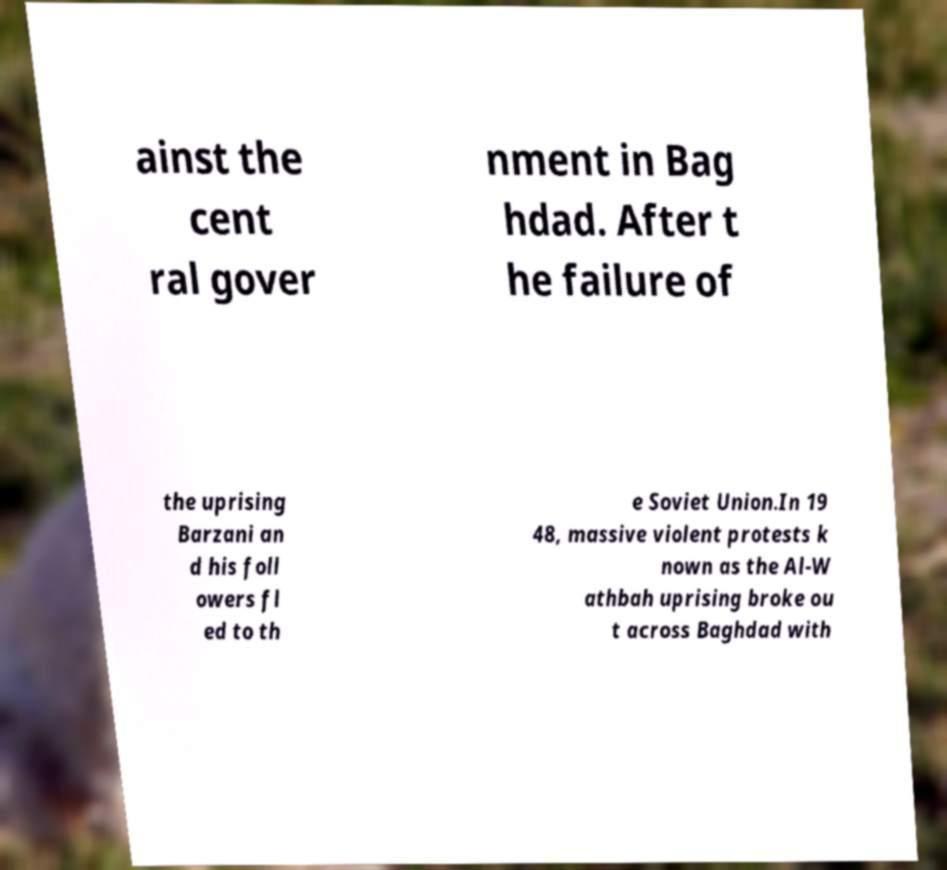I need the written content from this picture converted into text. Can you do that? ainst the cent ral gover nment in Bag hdad. After t he failure of the uprising Barzani an d his foll owers fl ed to th e Soviet Union.In 19 48, massive violent protests k nown as the Al-W athbah uprising broke ou t across Baghdad with 